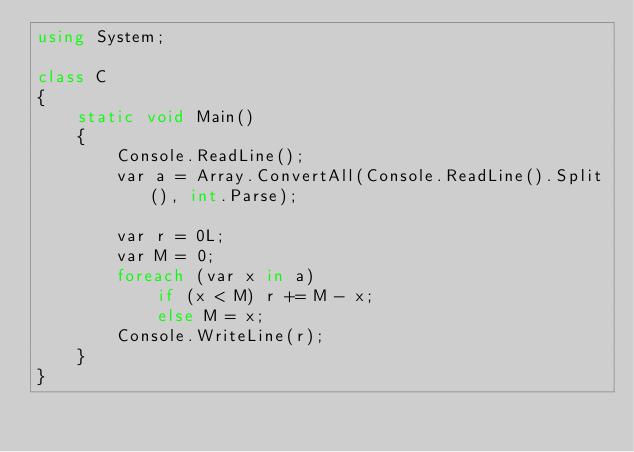Convert code to text. <code><loc_0><loc_0><loc_500><loc_500><_C#_>using System;

class C
{
	static void Main()
	{
		Console.ReadLine();
		var a = Array.ConvertAll(Console.ReadLine().Split(), int.Parse);

		var r = 0L;
		var M = 0;
		foreach (var x in a)
			if (x < M) r += M - x;
			else M = x;
		Console.WriteLine(r);
	}
}
</code> 